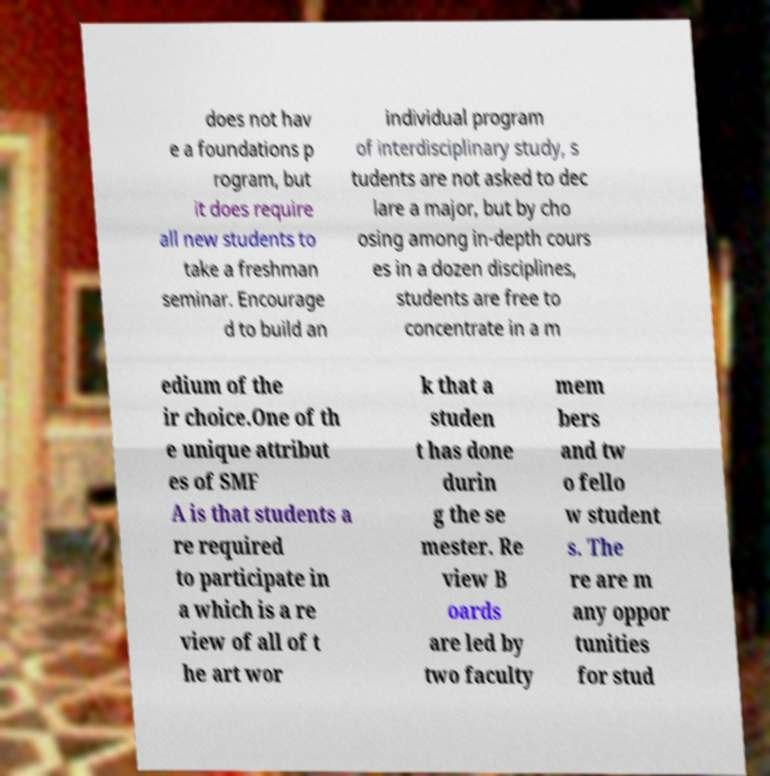Could you assist in decoding the text presented in this image and type it out clearly? does not hav e a foundations p rogram, but it does require all new students to take a freshman seminar. Encourage d to build an individual program of interdisciplinary study, s tudents are not asked to dec lare a major, but by cho osing among in-depth cours es in a dozen disciplines, students are free to concentrate in a m edium of the ir choice.One of th e unique attribut es of SMF A is that students a re required to participate in a which is a re view of all of t he art wor k that a studen t has done durin g the se mester. Re view B oards are led by two faculty mem bers and tw o fello w student s. The re are m any oppor tunities for stud 